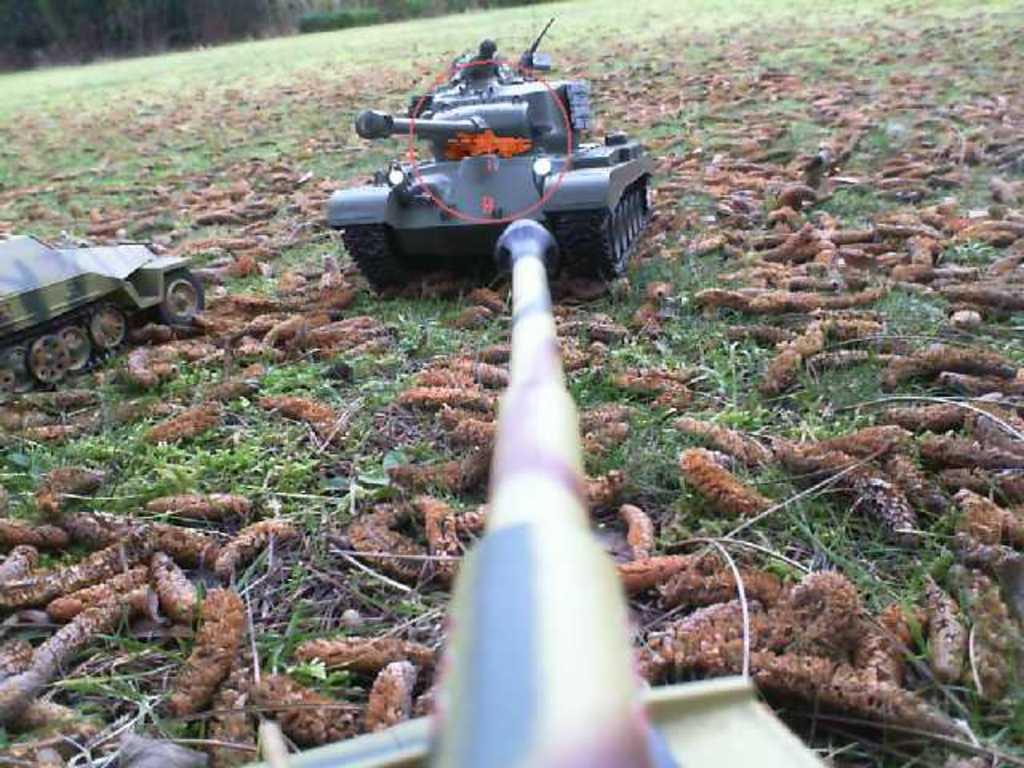What types of objects are present in the image? There are vehicles and worms in the image. What is the setting of the image? The image features grass and plants in the background. Can you describe the environment in the image? The environment includes grass and plants, suggesting it might be outdoors. How many pizzas are being served on the scale in the image? There is no scale or pizzas present in the image. What type of wax is being used to create the worm sculptures in the image? There are no sculptures or wax mentioned in the image; it features real worms. 